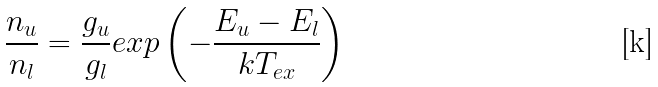<formula> <loc_0><loc_0><loc_500><loc_500>\frac { n _ { u } } { n _ { l } } = \frac { g _ { u } } { g _ { l } } e x p \left ( - \frac { E _ { u } - E _ { l } } { k T _ { e x } } \right )</formula> 